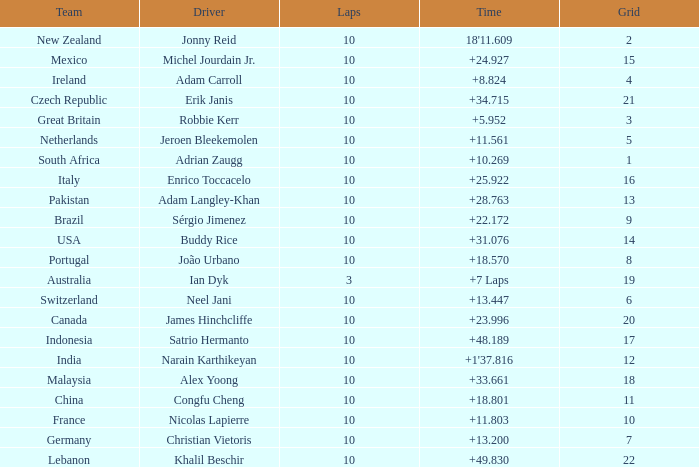What team had 10 Labs and the Driver was Alex Yoong? Malaysia. 